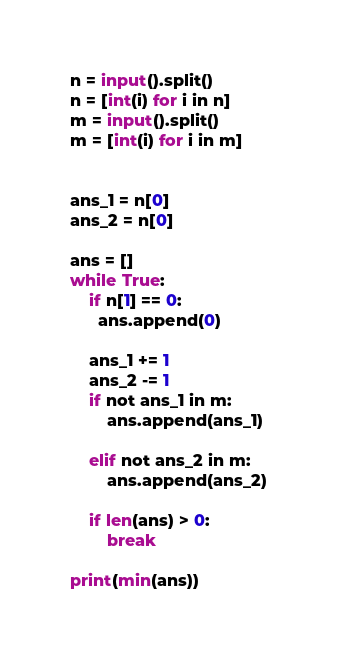Convert code to text. <code><loc_0><loc_0><loc_500><loc_500><_Python_>n = input().split()
n = [int(i) for i in n]
m = input().split()
m = [int(i) for i in m]


ans_1 = n[0]
ans_2 = n[0]

ans = []
while True:
  	if n[1] == 0:
      ans.append(0)
      
    ans_1 += 1
    ans_2 -= 1
    if not ans_1 in m:
        ans.append(ans_1)
        
    elif not ans_2 in m:
        ans.append(ans_2)
    
    if len(ans) > 0:
        break
        
print(min(ans))</code> 